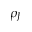Convert formula to latex. <formula><loc_0><loc_0><loc_500><loc_500>\rho _ { J }</formula> 